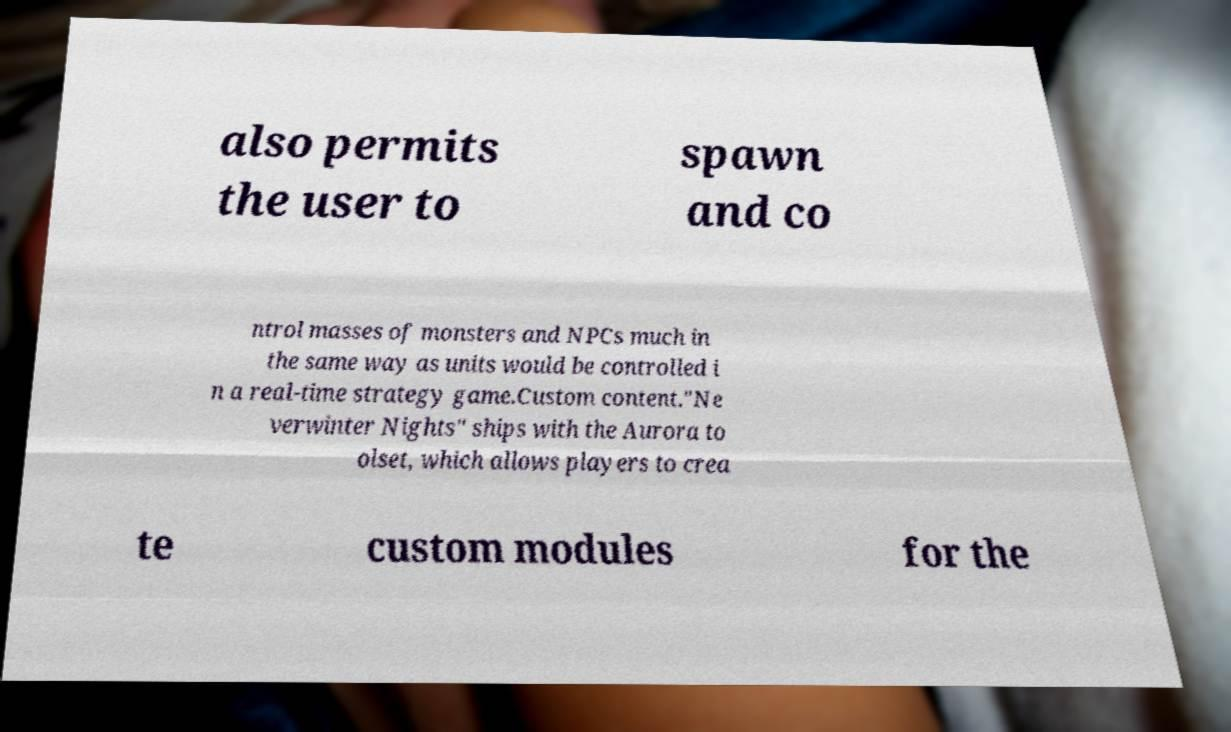Please identify and transcribe the text found in this image. also permits the user to spawn and co ntrol masses of monsters and NPCs much in the same way as units would be controlled i n a real-time strategy game.Custom content."Ne verwinter Nights" ships with the Aurora to olset, which allows players to crea te custom modules for the 